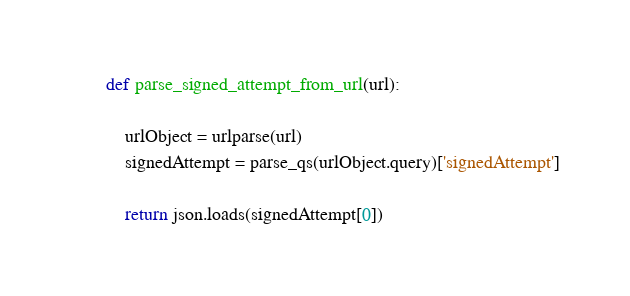<code> <loc_0><loc_0><loc_500><loc_500><_Python_>

def parse_signed_attempt_from_url(url):

    urlObject = urlparse(url)
    signedAttempt = parse_qs(urlObject.query)['signedAttempt']

    return json.loads(signedAttempt[0])


</code> 